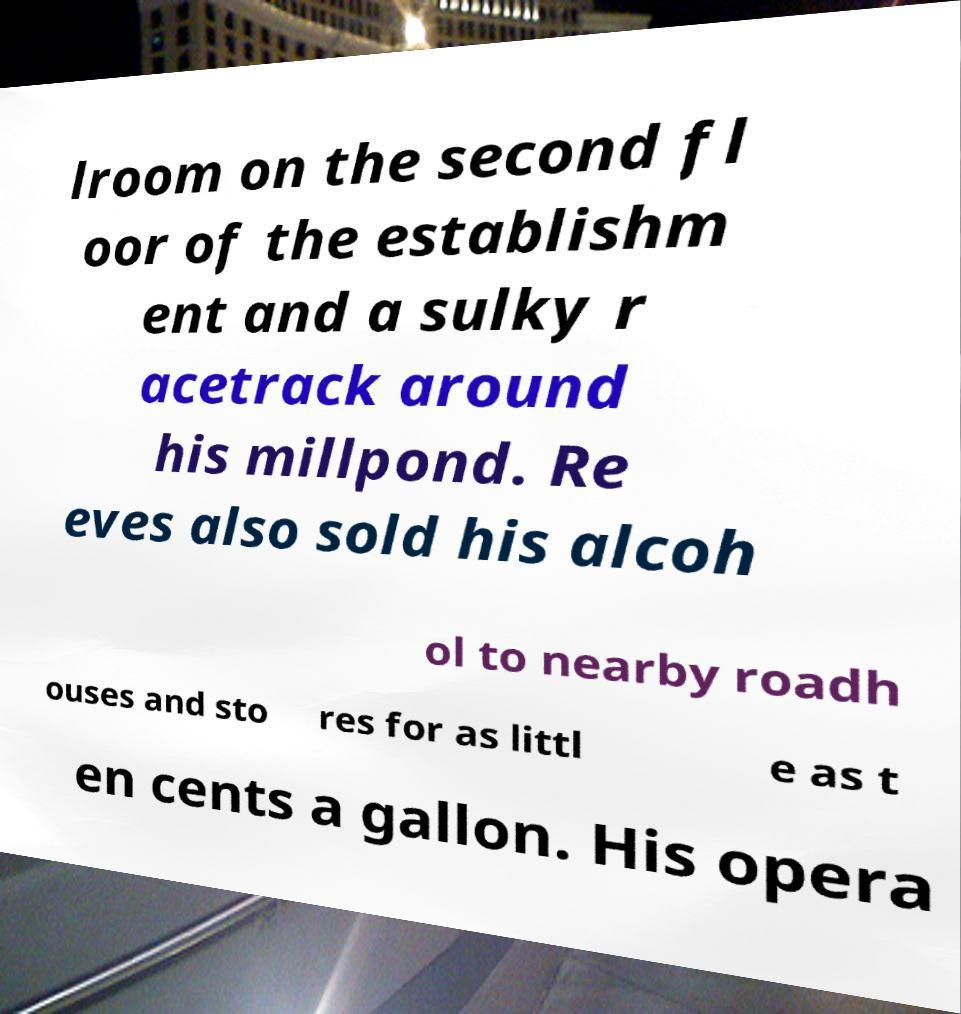Can you accurately transcribe the text from the provided image for me? lroom on the second fl oor of the establishm ent and a sulky r acetrack around his millpond. Re eves also sold his alcoh ol to nearby roadh ouses and sto res for as littl e as t en cents a gallon. His opera 